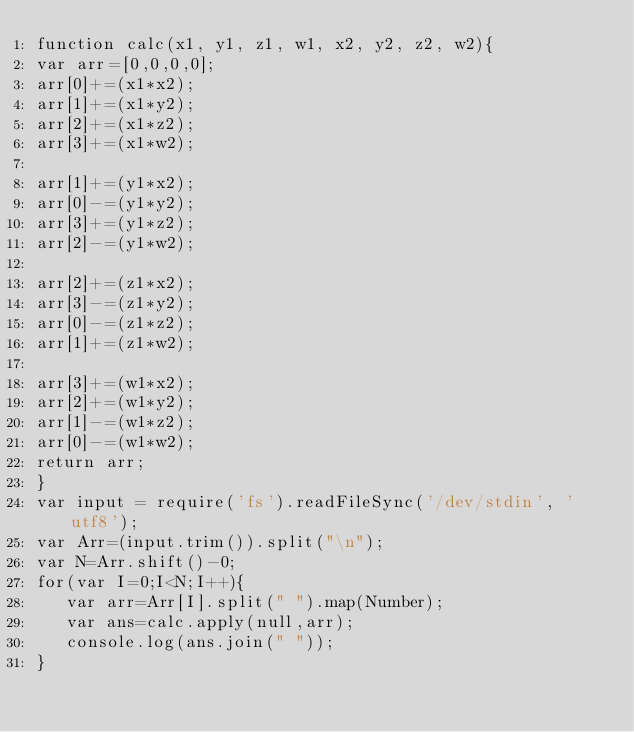<code> <loc_0><loc_0><loc_500><loc_500><_JavaScript_>function calc(x1, y1, z1, w1, x2, y2, z2, w2){ 
var arr=[0,0,0,0];
arr[0]+=(x1*x2);
arr[1]+=(x1*y2);
arr[2]+=(x1*z2);
arr[3]+=(x1*w2);

arr[1]+=(y1*x2);
arr[0]-=(y1*y2);
arr[3]+=(y1*z2);
arr[2]-=(y1*w2);

arr[2]+=(z1*x2);
arr[3]-=(z1*y2);
arr[0]-=(z1*z2);
arr[1]+=(z1*w2);

arr[3]+=(w1*x2);
arr[2]+=(w1*y2);
arr[1]-=(w1*z2);
arr[0]-=(w1*w2);
return arr;
}
var input = require('fs').readFileSync('/dev/stdin', 'utf8');
var Arr=(input.trim()).split("\n");
var N=Arr.shift()-0;
for(var I=0;I<N;I++){
   var arr=Arr[I].split(" ").map(Number);
   var ans=calc.apply(null,arr);
   console.log(ans.join(" "));
}</code> 